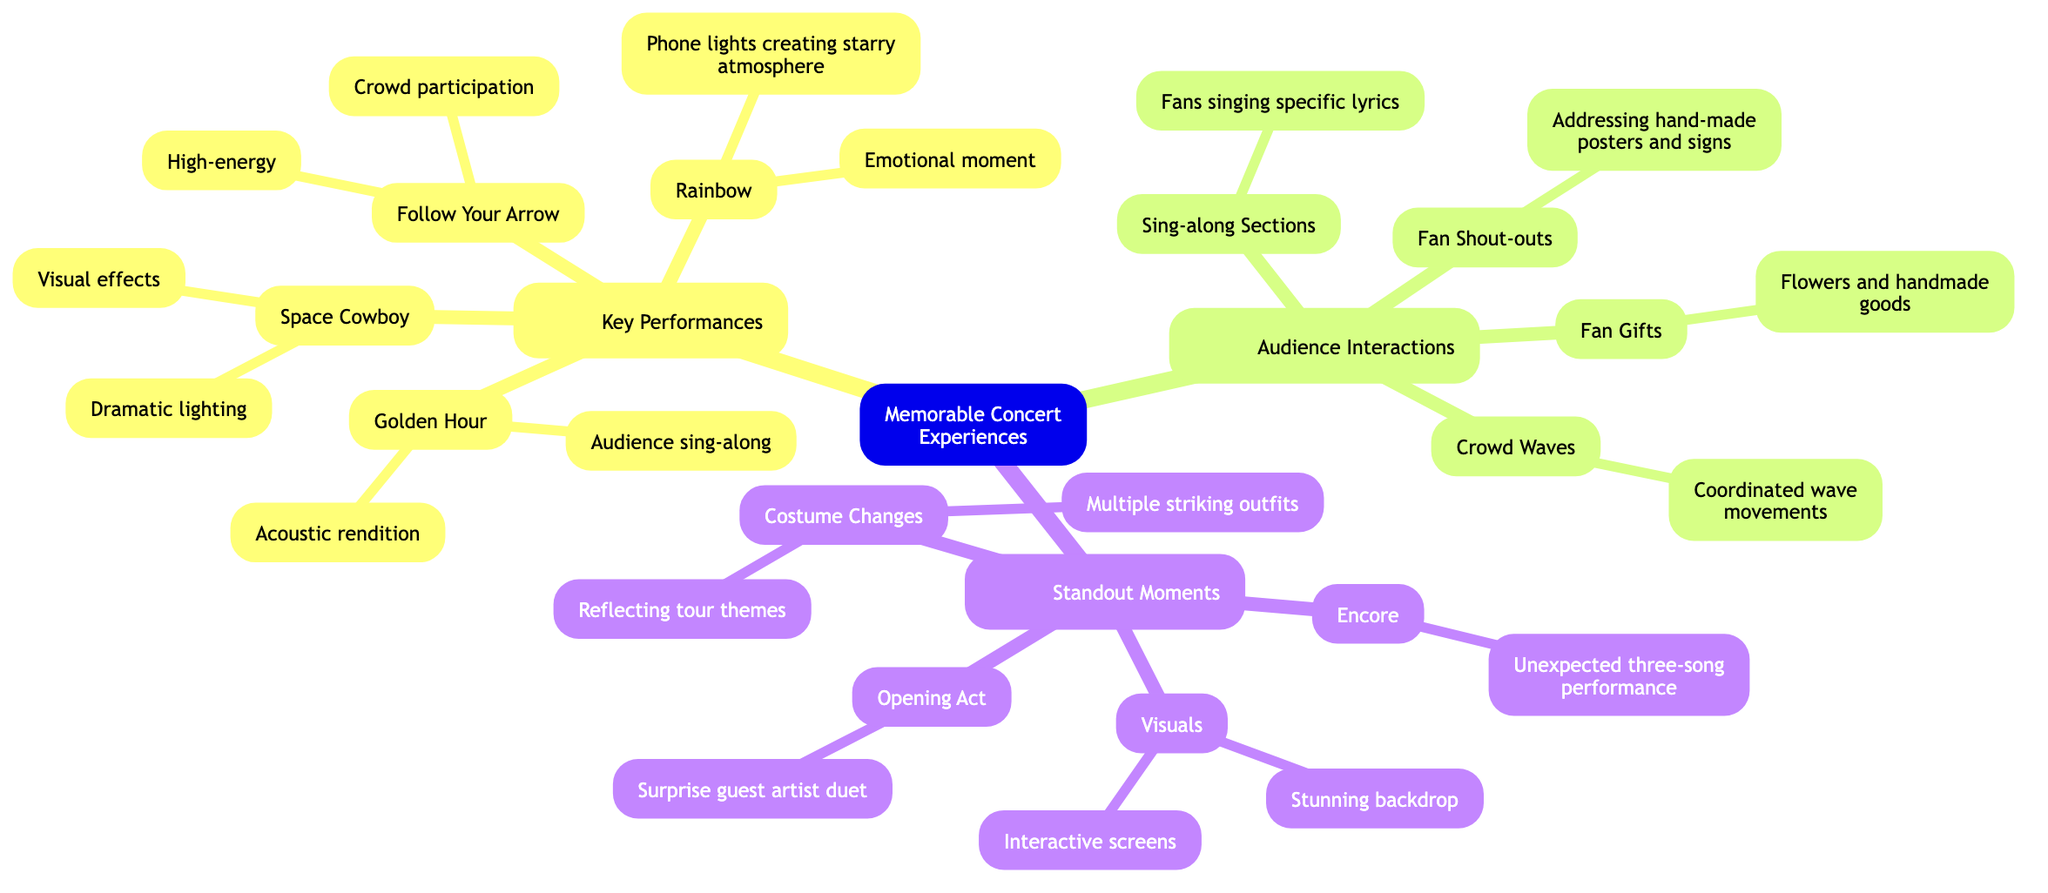What are the two songs that feature audience participation? The diagram highlights "Follow Your Arrow" for high-energy crowd participation and "Golden Hour" for audience sing-along. Both songs illustrate significant audience interactions during the concert.
Answer: Follow Your Arrow, Golden Hour How many standout moments are listed in the diagram? In the Standout Moments section, there are four specific moments mentioned: Opening Act, Encore, Visuals, and Costume Changes. Therefore, to find the total, we count these listed items.
Answer: 4 What performance is associated with emotional moments? The diagram specifically indicates "Rainbow" as having an emotional moment enhanced by phone lights creating a starry atmosphere, establishing it as a notable performance for emotional interaction.
Answer: Rainbow What type of audience interaction involves movements during songs? "Crowd Waves" is the type of audience interaction that includes coordinated wave movements during multiple songs, reflecting audience engagement and participation.
Answer: Crowd Waves Which performance features dramatic lighting? "Space Cowboy" is noted in the diagram for featuring dramatic lighting and visual effects, highlighting its impressive presentation during the concert.
Answer: Space Cowboy How many key performances are mentioned? In the Key Performances section, the diagram lists four performances: Golden Hour, Follow Your Arrow, Space Cowboy, and Rainbow. Counting these entries gives us the number of key performances.
Answer: 4 What is highlighted about the encore? The encore is highlighted as an unexpected three-song performance, indicating a surprise element that added to the concert's overall experience according to the diagram.
Answer: Unexpected three-song performance What did fans give to Kacey on stage? The diagram notes that fans presented flowers and handmade goods to Kacey on stage, showcasing the supportive interaction between the artist and the audience.
Answer: Flowers and handmade goods Which song had an acoustic rendition? "Golden Hour" is specifically mentioned as having an acoustic rendition, pointing to its unique performance style during the concert.
Answer: Golden Hour 